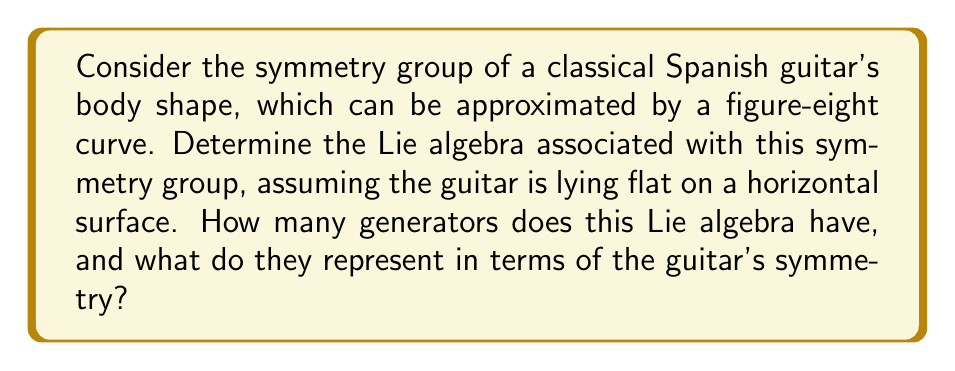Can you solve this math problem? To solve this problem, let's approach it step-by-step:

1) First, we need to identify the symmetries of a classical Spanish guitar's body shape. When lying flat, the guitar's body has two main symmetries:
   a) Reflection across its longitudinal axis
   b) 180-degree rotation around its center

2) These symmetries form a group isomorphic to $\mathbb{Z}_2 \times \mathbb{Z}_2$, where $\mathbb{Z}_2$ is the cyclic group of order 2.

3) However, Lie algebras are associated with continuous symmetries, not discrete ones. The discrete symmetry group we've identified doesn't have a non-trivial Lie algebra associated with it.

4) To find a non-trivial Lie algebra, we need to consider continuous symmetries. The only continuous symmetry of the guitar's body shape is rotations around the axis perpendicular to the guitar's plane (i.e., the vertical axis when the guitar is lying flat).

5) These rotations form a group isomorphic to SO(2), the special orthogonal group in 2 dimensions.

6) The Lie algebra associated with SO(2) is so(2), which is a one-dimensional Lie algebra.

7) The generator of so(2) can be represented by the matrix:

   $$J = \begin{pmatrix} 0 & -1 \\ 1 & 0 \end{pmatrix}$$

8) This generator represents infinitesimal rotations around the vertical axis of the guitar.

Therefore, the Lie algebra associated with the continuous symmetry group of the guitar's body shape is so(2), which has one generator.
Answer: The Lie algebra associated with the symmetry group of the guitar's body shape is so(2), which has 1 generator. This generator represents infinitesimal rotations around the axis perpendicular to the guitar's plane. 